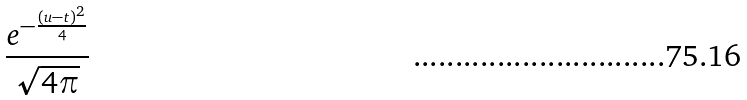<formula> <loc_0><loc_0><loc_500><loc_500>\frac { e ^ { - { \frac { ( u - t ) ^ { 2 } } { 4 } } } } { \sqrt { 4 \pi } }</formula> 